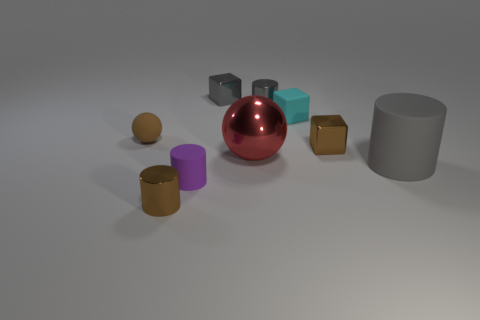Is the lighting coming from a specific direction, and how does that affect the appearance of the objects? The lighting seems to be coming from the upper right. This creates shadows on the opposite side of each object, giving a sense of depth and dimension to the scene. Do the shadows tell us anything about the texture or material of the objects? Yes, the sharpness and darkness of the shadows suggest that the surfaces are matte or non-reflective, as opposed to shiny or reflective surfaces which would create softer, less defined shadows. 